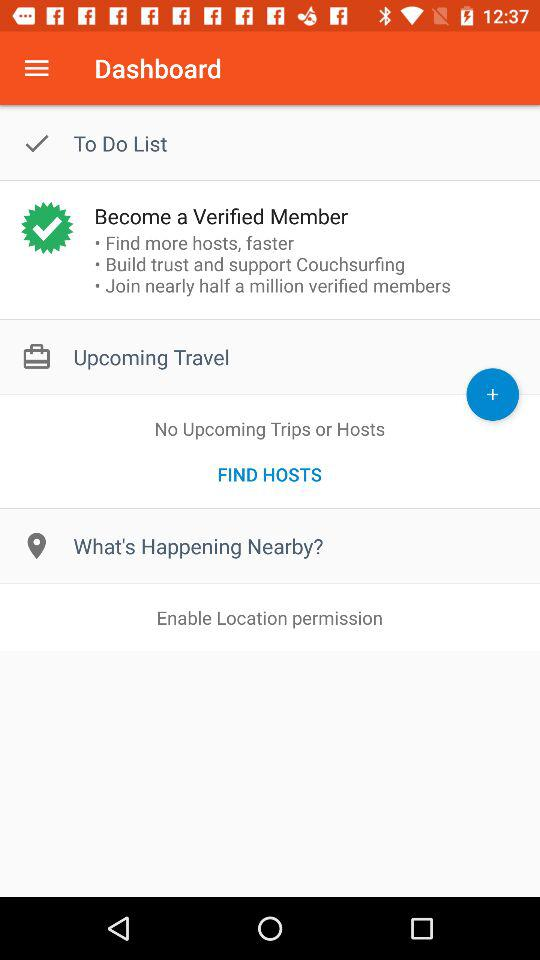Are there any upcoming trips or hosts? There are no upcoming trips or hosts. 